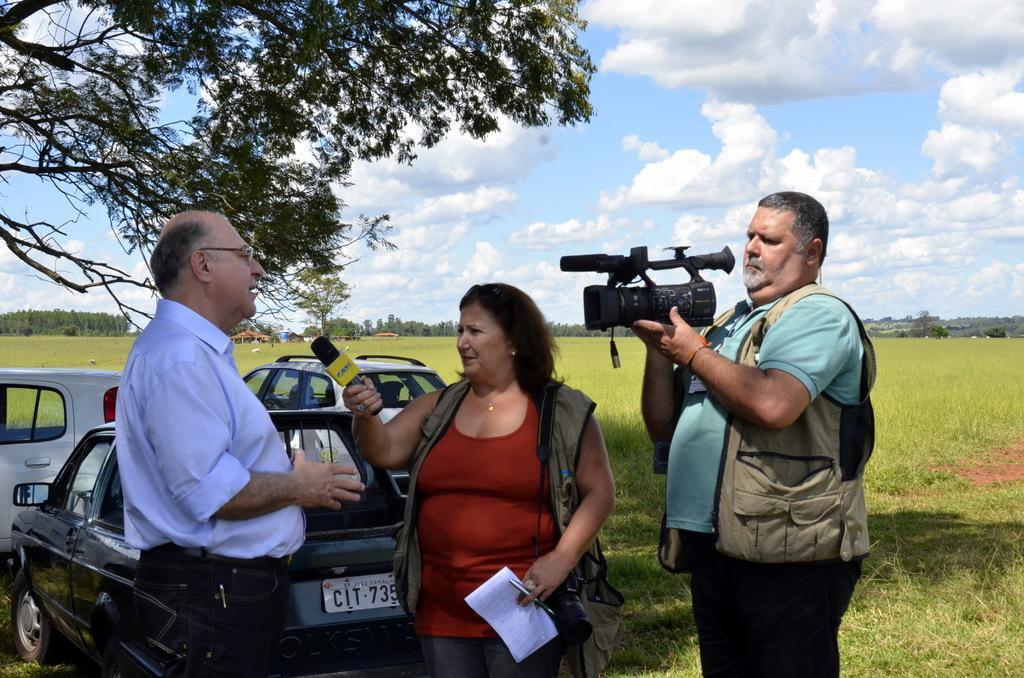Could you give a brief overview of what you see in this image? This is a picture taken in the outdoors. It is sunny. The man in blue t shirt holding a camera and the woman in red t shirt holding a microphone and a paper in front of these people there is other man is standing on the floor. Background of these people there are cars, field, trees and sky. 